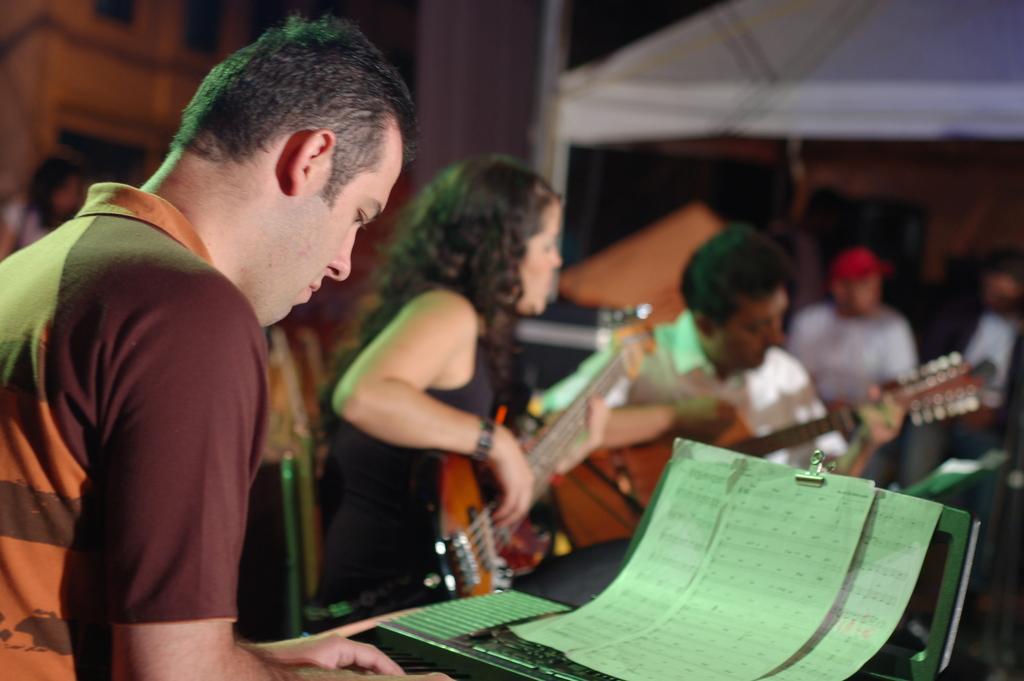Could you give a brief overview of what you see in this image? In the foreground of this picture, there is a man playing keyboard and there are three papers in front of him. In the background, there are persons playing guitar, a tent, pillar and a building. 